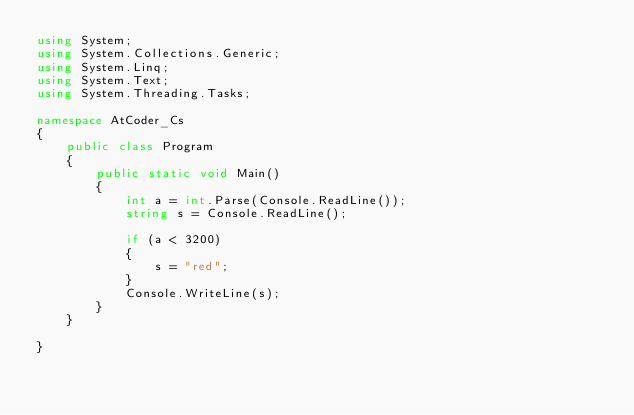Convert code to text. <code><loc_0><loc_0><loc_500><loc_500><_C#_>using System;
using System.Collections.Generic;
using System.Linq;
using System.Text;
using System.Threading.Tasks;

namespace AtCoder_Cs
{
    public class Program
    {
        public static void Main()
        {
            int a = int.Parse(Console.ReadLine());
            string s = Console.ReadLine();

            if (a < 3200)
            {
                s = "red";
            }
            Console.WriteLine(s);
        }
    }

}
</code> 